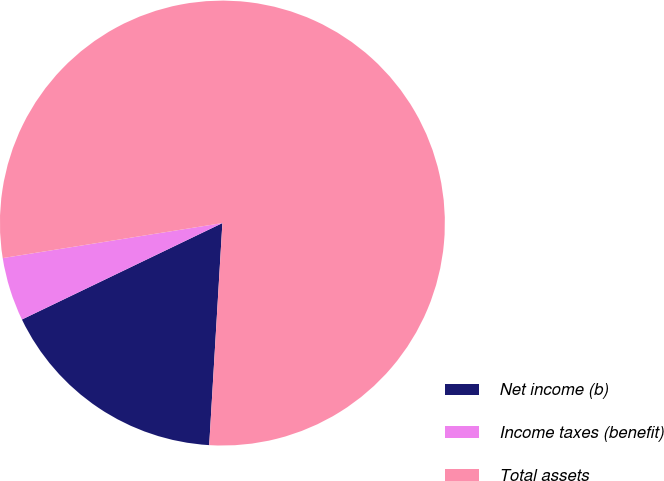<chart> <loc_0><loc_0><loc_500><loc_500><pie_chart><fcel>Net income (b)<fcel>Income taxes (benefit)<fcel>Total assets<nl><fcel>16.92%<fcel>4.62%<fcel>78.46%<nl></chart> 